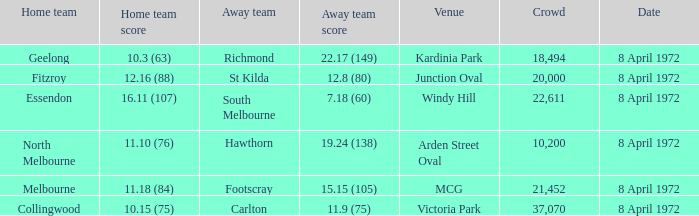Which Venue has a Home team of geelong? Kardinia Park. 